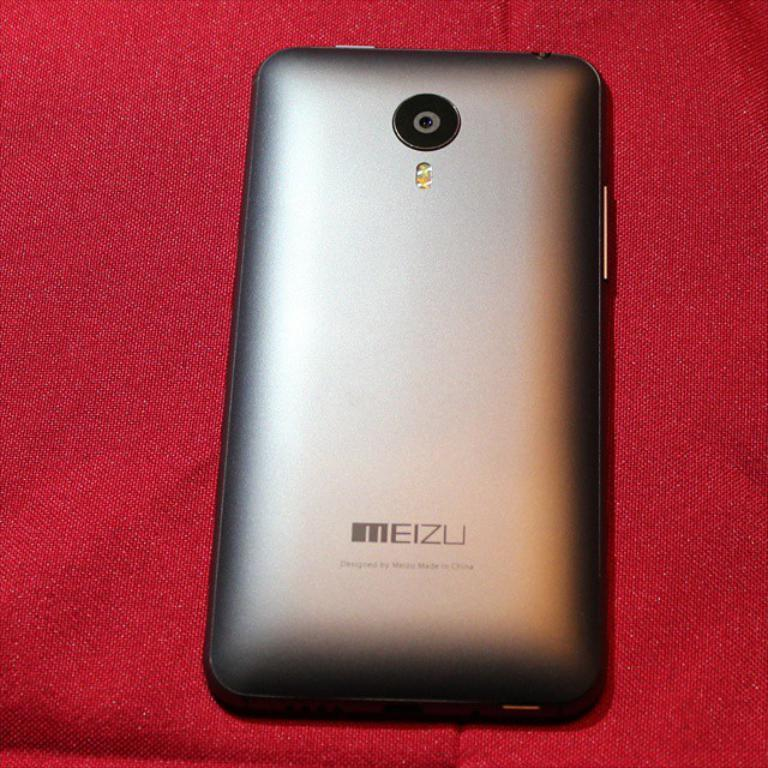<image>
Relay a brief, clear account of the picture shown. The back of a Meizli camera cell phone. 